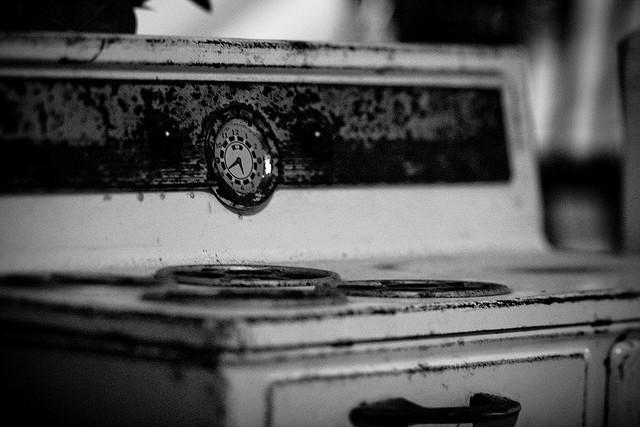Is this a gas stove?
Be succinct. Yes. Where is the timer?
Keep it brief. Stove. Would you be prepared to cook a meal on this stove?
Answer briefly. No. Is the stove old and filthy?
Give a very brief answer. Yes. 